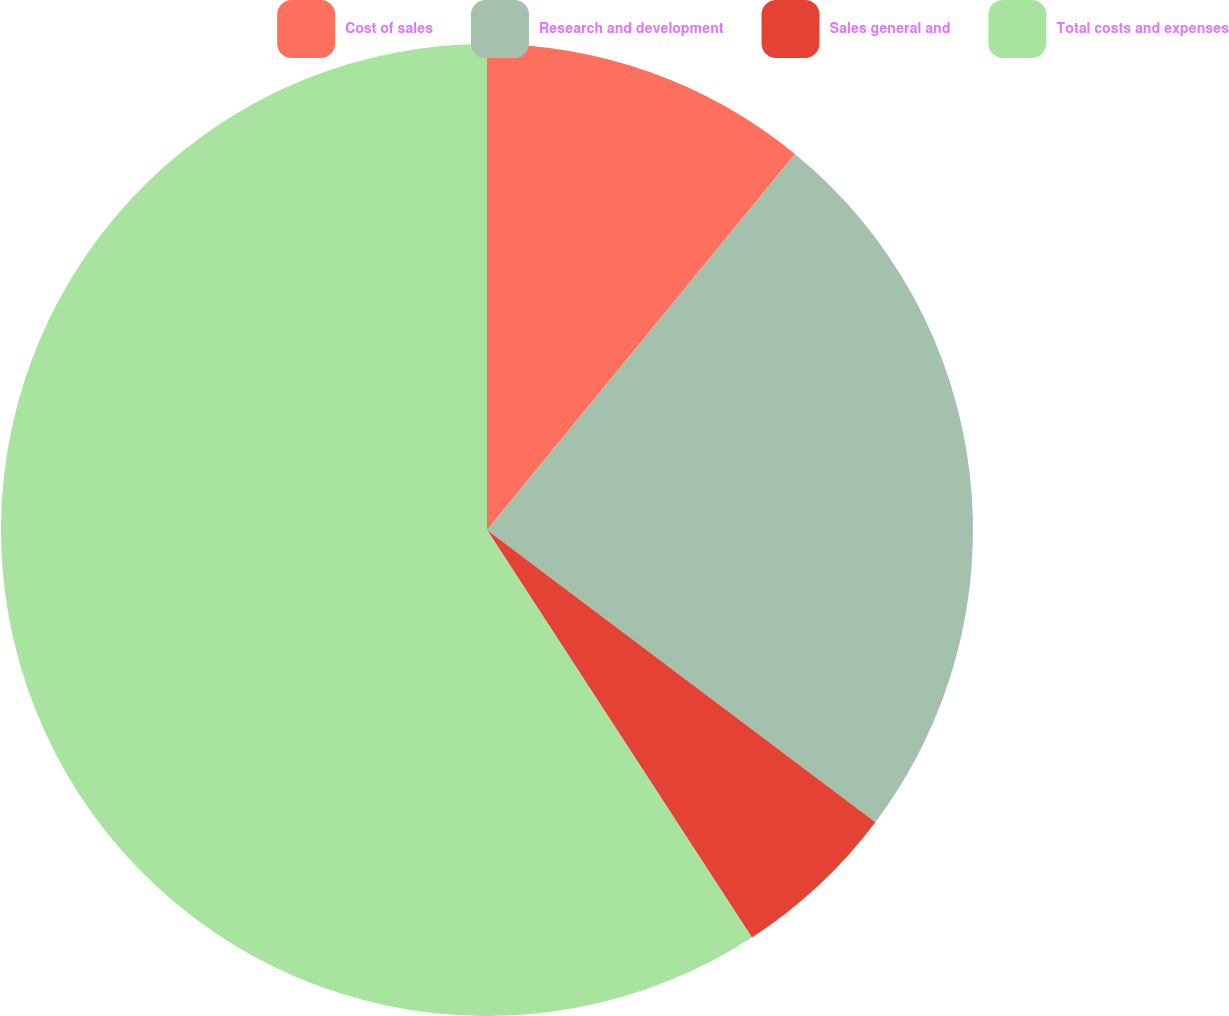Convert chart. <chart><loc_0><loc_0><loc_500><loc_500><pie_chart><fcel>Cost of sales<fcel>Research and development<fcel>Sales general and<fcel>Total costs and expenses<nl><fcel>10.92%<fcel>24.34%<fcel>5.56%<fcel>59.17%<nl></chart> 